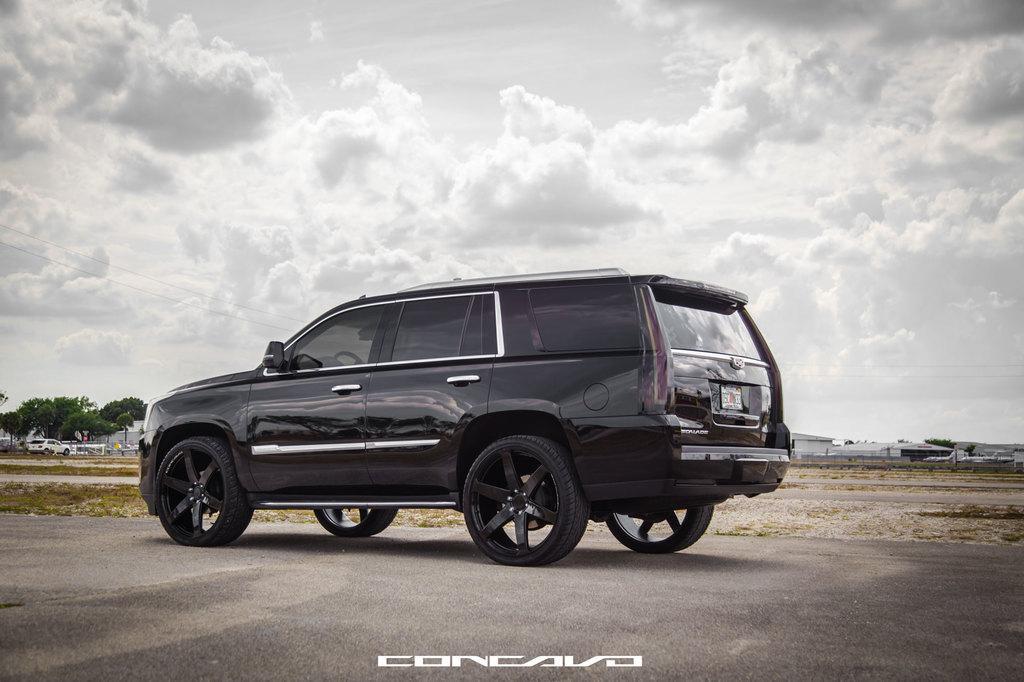Please provide a concise description of this image. At the bottom it is road. In the middle there is a car. In the center of the picture there are trees, buildings, grass, car and various objects. At the top it is sky. 